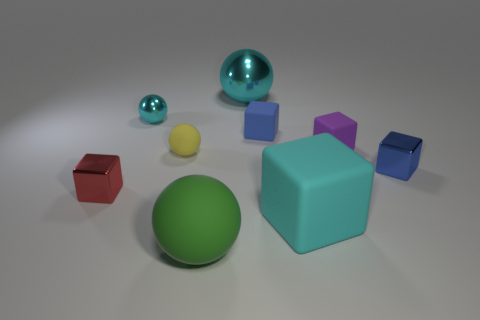What number of objects are tiny blue blocks in front of the purple matte object or balls in front of the tiny yellow rubber sphere?
Keep it short and to the point. 2. The yellow thing is what shape?
Make the answer very short. Sphere. How many other things are there of the same material as the yellow ball?
Ensure brevity in your answer.  4. There is a red thing that is the same shape as the blue metallic object; what is its size?
Provide a succinct answer. Small. The cyan object right of the tiny blue matte thing in front of the shiny sphere to the right of the yellow rubber ball is made of what material?
Ensure brevity in your answer.  Rubber. Is there a big red cube?
Offer a terse response. No. There is a large block; is its color the same as the large sphere behind the big matte ball?
Offer a very short reply. Yes. The big metallic object has what color?
Keep it short and to the point. Cyan. There is another shiny thing that is the same shape as the big cyan metal thing; what color is it?
Provide a short and direct response. Cyan. Do the purple thing and the large green matte thing have the same shape?
Give a very brief answer. No. 